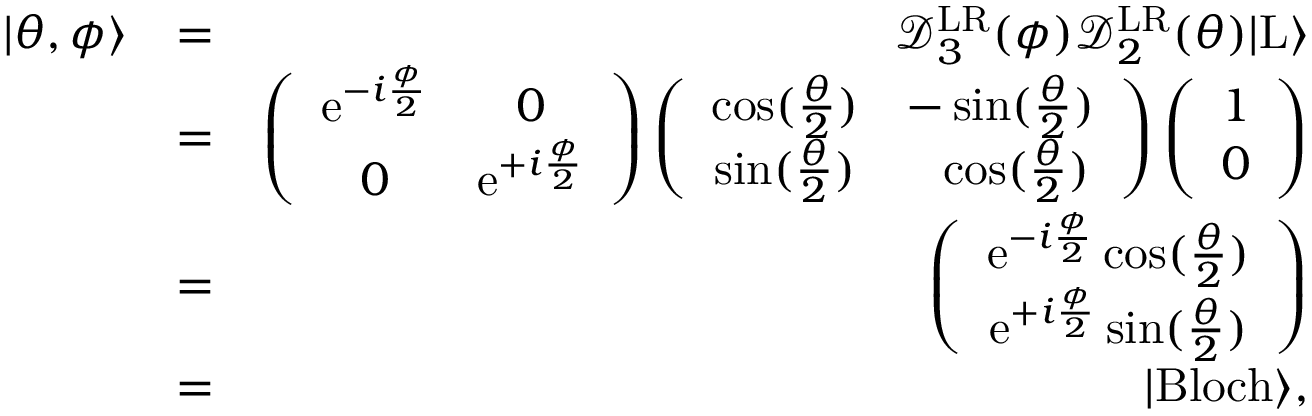Convert formula to latex. <formula><loc_0><loc_0><loc_500><loc_500>\begin{array} { r l r } { | \theta , \phi \rangle } & { = } & { \mathcal { D } _ { 3 } ^ { L R } ( \phi ) \mathcal { D } _ { 2 } ^ { L R } ( \theta ) | L \rangle } \\ & { = } & { \left ( \begin{array} { c c } { e ^ { - i \frac { \phi } { 2 } } } & { 0 } \\ { 0 } & { e ^ { + i \frac { \phi } { 2 } } } \end{array} \right ) \left ( \begin{array} { c c } { \cos ( \frac { \theta } { 2 } ) } & { - \sin ( \frac { \theta } { 2 } ) } \\ { \sin ( \frac { \theta } { 2 } ) } & { \quad \cos ( \frac { \theta } { 2 } ) } \end{array} \right ) \left ( \begin{array} { c } { 1 } \\ { 0 } \end{array} \right ) } \\ & { = } & { \left ( \begin{array} { c } { e ^ { - i \frac { \phi } { 2 } } \cos ( \frac { \theta } { 2 } ) } \\ { e ^ { + i \frac { \phi } { 2 } } \sin ( \frac { \theta } { 2 } ) } \end{array} \right ) } \\ & { = } & { | B l o c h \rangle , } \end{array}</formula> 